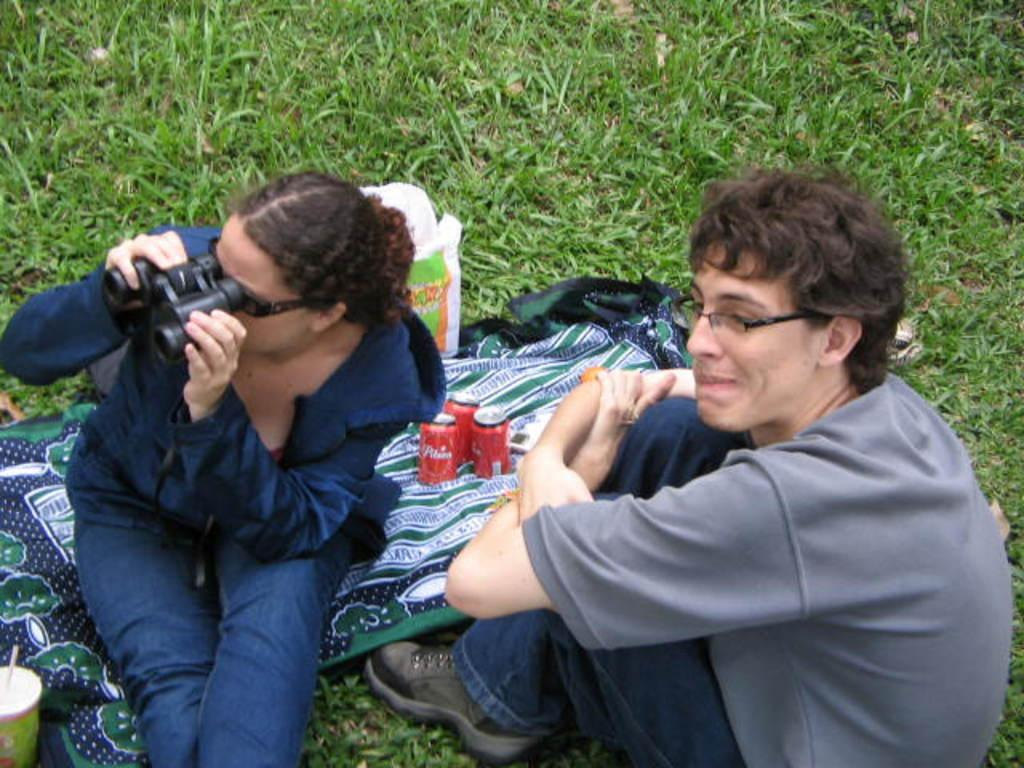What is the woman in the image doing? The woman is sitting on a cloth and holding a binocular telescope. Who else is present in the image? There is a person sitting on the grass in the image. What object can be seen near the woman? A cup is visible in the image. What type of vegetation is present in the image? Grass is present in the image. What type of rail can be seen in the image? There is no rail present in the image. What is the woman cooking in the image? There is no indication that the woman is cooking in the image; she is holding a binocular telescope. 